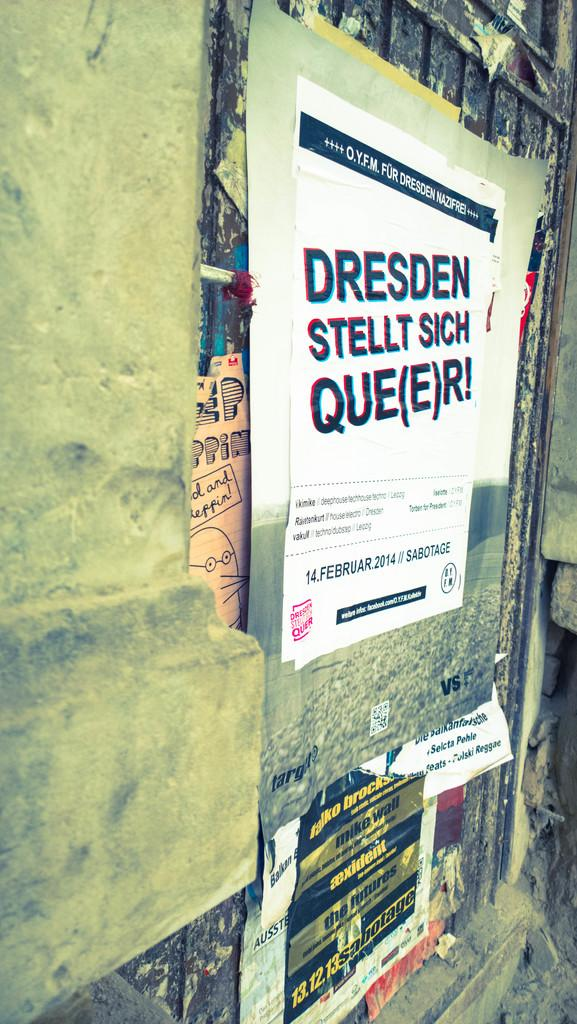<image>
Offer a succinct explanation of the picture presented. An advertisement on a wall for Dresden Stellt Sich Que(e)r! for February 14, 2014. 